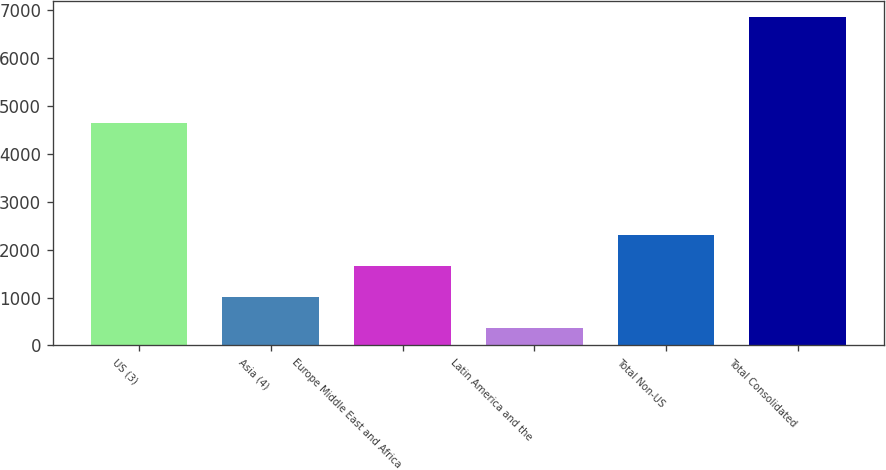Convert chart to OTSL. <chart><loc_0><loc_0><loc_500><loc_500><bar_chart><fcel>US (3)<fcel>Asia (4)<fcel>Europe Middle East and Africa<fcel>Latin America and the<fcel>Total Non-US<fcel>Total Consolidated<nl><fcel>4643<fcel>1005<fcel>1655<fcel>355<fcel>2305<fcel>6855<nl></chart> 